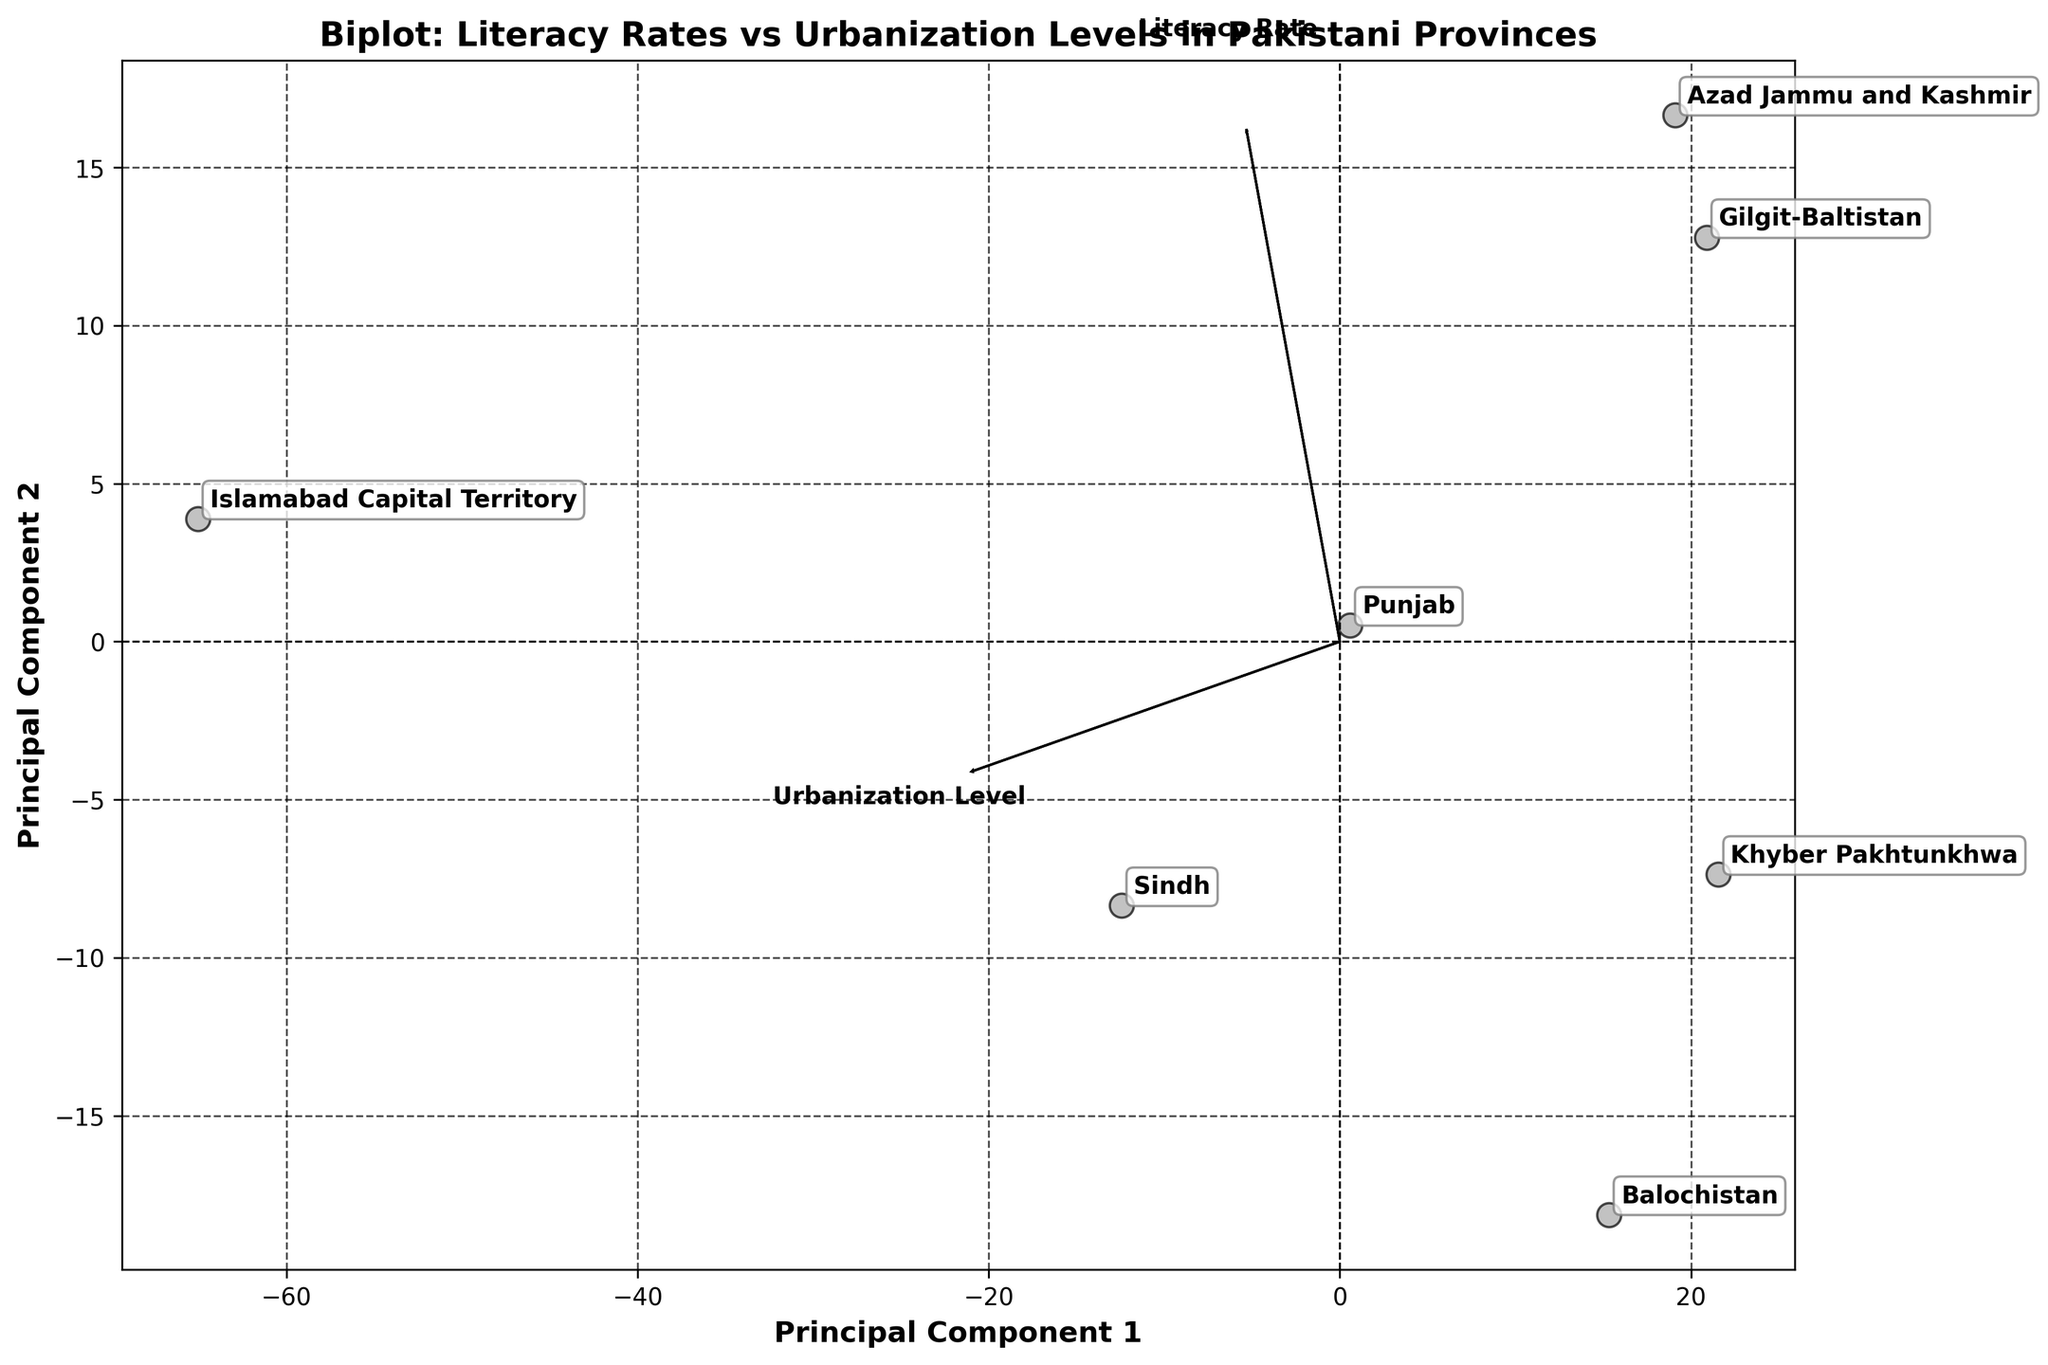What is the title of the figure? The title is usually positioned at the top of the plot and provides a brief description of the visual.
Answer: Biplot: Literacy Rates vs Urbanization Levels in Pakistani Provinces What do the arrows in the biplot represent? In a biplot, the arrows are used to represent the feature vectors—in this case, "Literacy Rate" and "Urbanization Level". They indicate the direction and magnitude of these features in the principal component space.
Answer: Feature vectors for Literacy Rate and Urbanization Level How many provinces are represented in the plot? The number of provinces is equal to the number of different labeled points in the scatter plot. Counting these labeled points gives the total number of provinces.
Answer: 7 Which province has the highest literacy rate? The province with the highest literacy rate will be the point furthest along the direction of the "Literacy Rate" arrow. Checking the figure, Islamabad Capital Territory is the farthest in that direction.
Answer: Islamabad Capital Territory Which province has the lowest urbanization level? The province with the lowest urbanization level will be the point furthest from the "Urbanization Level" arrow in the opposite direction. Checking the figure, Gilgit-Baltistan is the furthest in that direction.
Answer: Gilgit-Baltistan What is the principal component 1 and principal component 2 related to in the plot? Principal component 1 and 2 are the axes along which the data has been projected in the new space, explaining most of the variance in the data. They do not directly represent the original features but are a linear combination of them.
Answer: New axes explaining variance Which province has similar scores on both principal component 1 and principal component 2? Provinces with similar scores on both PC1 and PC2 will be close to the diagonal line that forms a 45-degree angle with the origin. A visual inspection indicates that Balochistan has similar scores on both PCs.
Answer: Balochistan Describe the relationship between Literacy Rate and Urbanization Level based on the biplot. The directions of the arrows for Literacy Rate and Urbanization Level indicate how these variables are correlated. Since both arrows point in similar directions, there is a positive correlation between them.
Answer: Positive correlation Which provinces appear to have the highest urbanization levels but lower literacy rates? Provinces with high urbanization levels but lower literacy rates will be positioned closer to the "Urbanization Level" arrow but not as close to the "Literacy Rate" arrow. Sindh fits this description.
Answer: Sindh What can be said about the literacy rate and urbanization level in the Punjab province based on the figure? Punjab will be positioned where its projected scores on the PCs fall. Since Punjab is neither far along any particular direction from the plot's origin, it indicates that it has moderate values for both literacy and urbanization.
Answer: Moderate values for both 